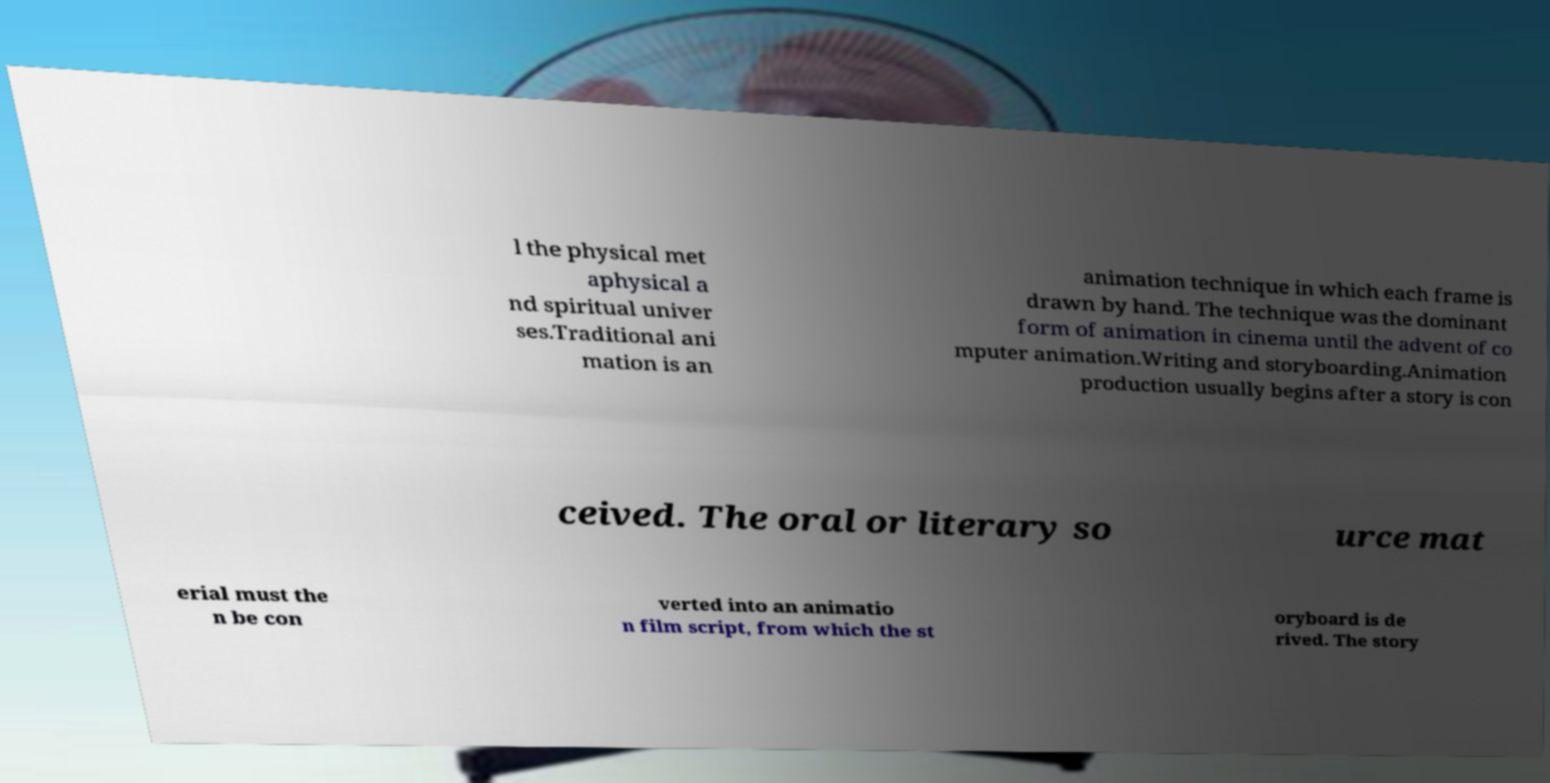Please identify and transcribe the text found in this image. l the physical met aphysical a nd spiritual univer ses.Traditional ani mation is an animation technique in which each frame is drawn by hand. The technique was the dominant form of animation in cinema until the advent of co mputer animation.Writing and storyboarding.Animation production usually begins after a story is con ceived. The oral or literary so urce mat erial must the n be con verted into an animatio n film script, from which the st oryboard is de rived. The story 